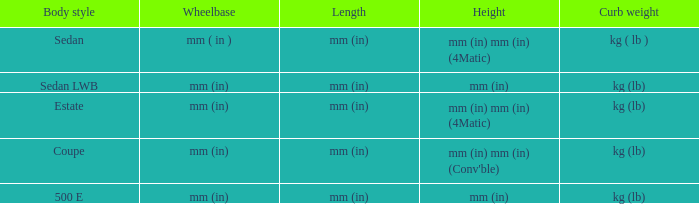What is the size of the models that are measured in millimeters (inches) in height? Mm (in), mm (in). Help me parse the entirety of this table. {'header': ['Body style', 'Wheelbase', 'Length', 'Height', 'Curb weight'], 'rows': [['Sedan', 'mm ( in )', 'mm (in)', 'mm (in) mm (in) (4Matic)', 'kg ( lb )'], ['Sedan LWB', 'mm (in)', 'mm (in)', 'mm (in)', 'kg (lb)'], ['Estate', 'mm (in)', 'mm (in)', 'mm (in) mm (in) (4Matic)', 'kg (lb)'], ['Coupe', 'mm (in)', 'mm (in)', "mm (in) mm (in) (Conv'ble)", 'kg (lb)'], ['500 E', 'mm (in)', 'mm (in)', 'mm (in)', 'kg (lb)']]} 